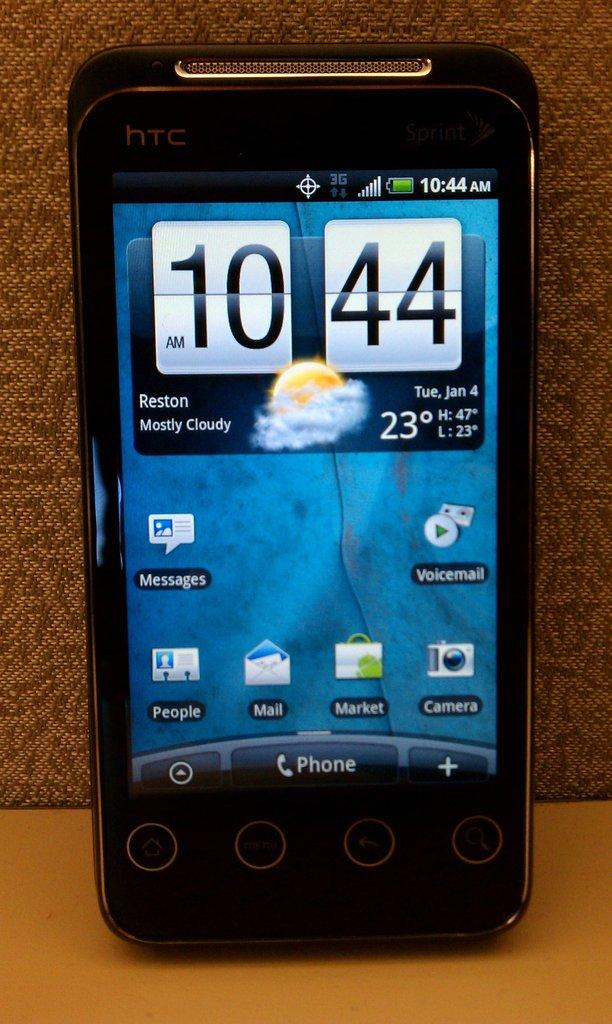Does this phone actually have service right now?
Ensure brevity in your answer.  Answering does not require reading text in the image. What is the time displayed on the smartphone screen?
Your answer should be compact. 10:44. 